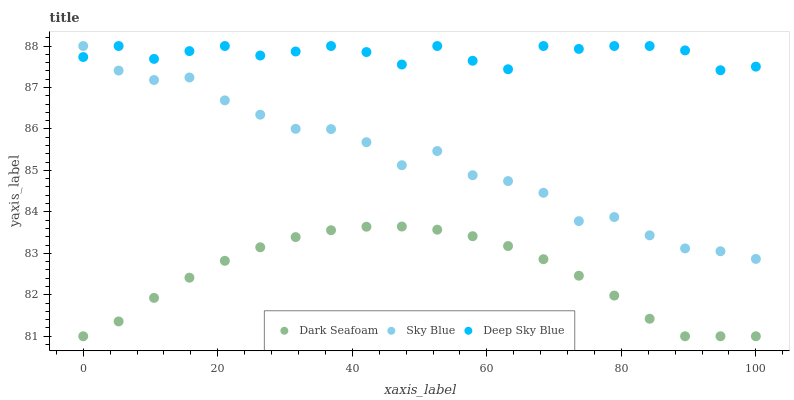Does Dark Seafoam have the minimum area under the curve?
Answer yes or no. Yes. Does Deep Sky Blue have the maximum area under the curve?
Answer yes or no. Yes. Does Deep Sky Blue have the minimum area under the curve?
Answer yes or no. No. Does Dark Seafoam have the maximum area under the curve?
Answer yes or no. No. Is Dark Seafoam the smoothest?
Answer yes or no. Yes. Is Sky Blue the roughest?
Answer yes or no. Yes. Is Deep Sky Blue the smoothest?
Answer yes or no. No. Is Deep Sky Blue the roughest?
Answer yes or no. No. Does Dark Seafoam have the lowest value?
Answer yes or no. Yes. Does Deep Sky Blue have the lowest value?
Answer yes or no. No. Does Deep Sky Blue have the highest value?
Answer yes or no. Yes. Does Dark Seafoam have the highest value?
Answer yes or no. No. Is Dark Seafoam less than Sky Blue?
Answer yes or no. Yes. Is Sky Blue greater than Dark Seafoam?
Answer yes or no. Yes. Does Deep Sky Blue intersect Sky Blue?
Answer yes or no. Yes. Is Deep Sky Blue less than Sky Blue?
Answer yes or no. No. Is Deep Sky Blue greater than Sky Blue?
Answer yes or no. No. Does Dark Seafoam intersect Sky Blue?
Answer yes or no. No. 